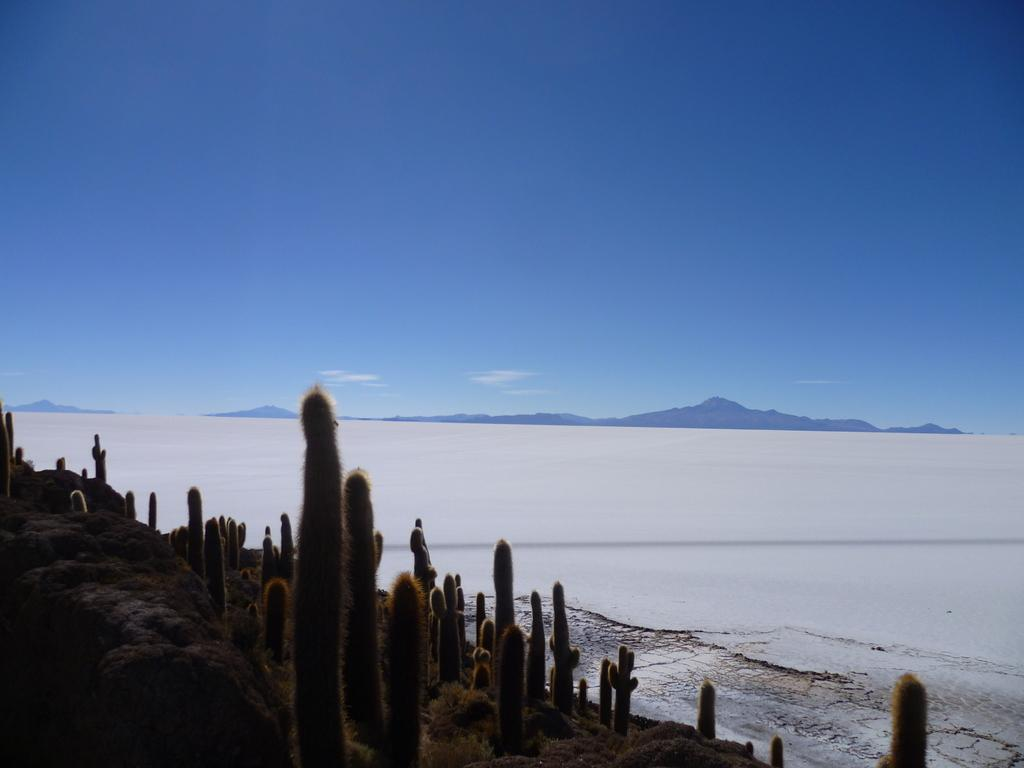What type of living organisms can be seen in the image? Plants can be seen in the image. What is the color of the snow in the background? The snow in the background is depicted in white color. What natural features are visible in the background of the image? Mountains are visible in the background of the image. What color is the sky in the image? The sky is blue in color. Is there a woman riding a bike on the mountains in the image? There is no woman or bike present in the image; it only features plants, snow, mountains, and a blue sky. 